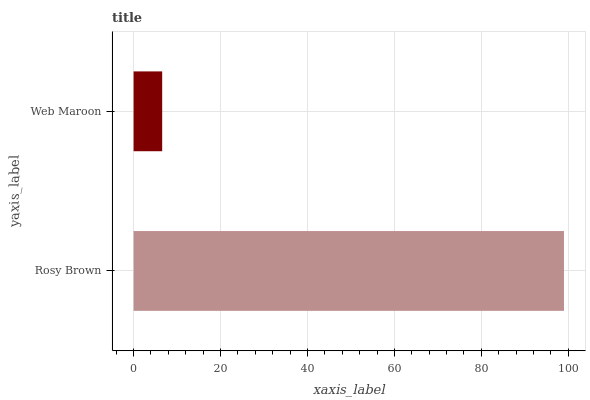Is Web Maroon the minimum?
Answer yes or no. Yes. Is Rosy Brown the maximum?
Answer yes or no. Yes. Is Web Maroon the maximum?
Answer yes or no. No. Is Rosy Brown greater than Web Maroon?
Answer yes or no. Yes. Is Web Maroon less than Rosy Brown?
Answer yes or no. Yes. Is Web Maroon greater than Rosy Brown?
Answer yes or no. No. Is Rosy Brown less than Web Maroon?
Answer yes or no. No. Is Rosy Brown the high median?
Answer yes or no. Yes. Is Web Maroon the low median?
Answer yes or no. Yes. Is Web Maroon the high median?
Answer yes or no. No. Is Rosy Brown the low median?
Answer yes or no. No. 